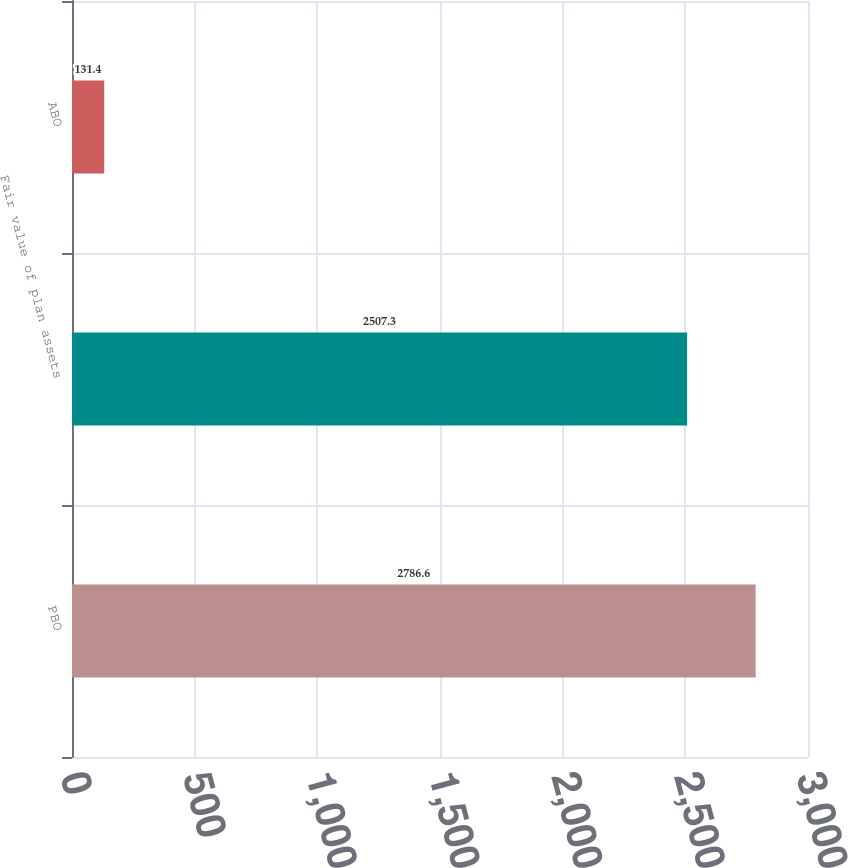Convert chart to OTSL. <chart><loc_0><loc_0><loc_500><loc_500><bar_chart><fcel>PBO<fcel>Fair value of plan assets<fcel>ABO<nl><fcel>2786.6<fcel>2507.3<fcel>131.4<nl></chart> 